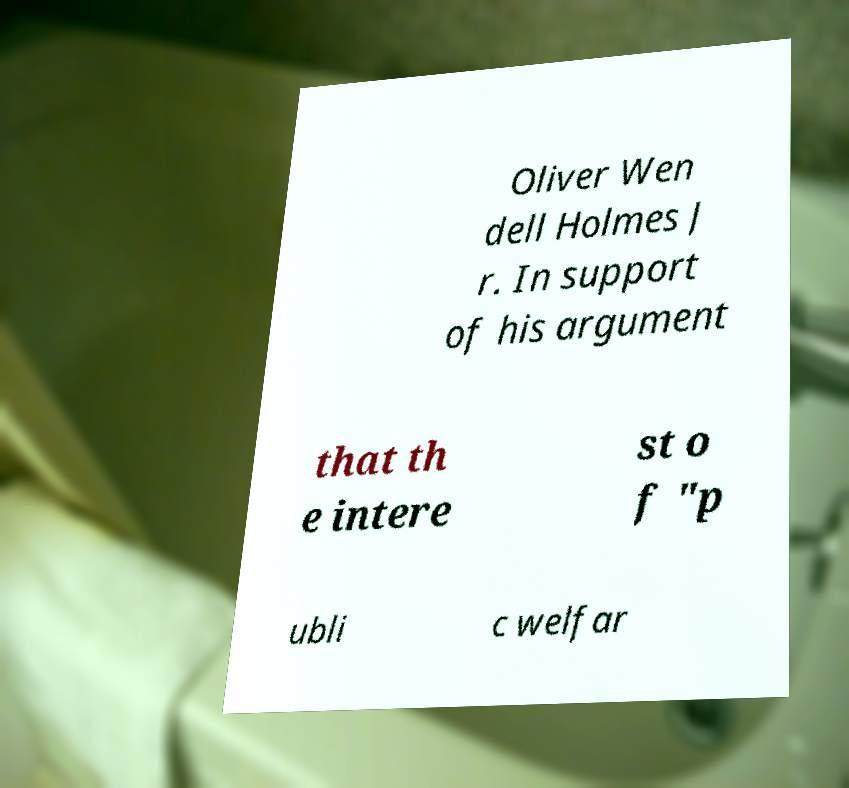I need the written content from this picture converted into text. Can you do that? Oliver Wen dell Holmes J r. In support of his argument that th e intere st o f "p ubli c welfar 